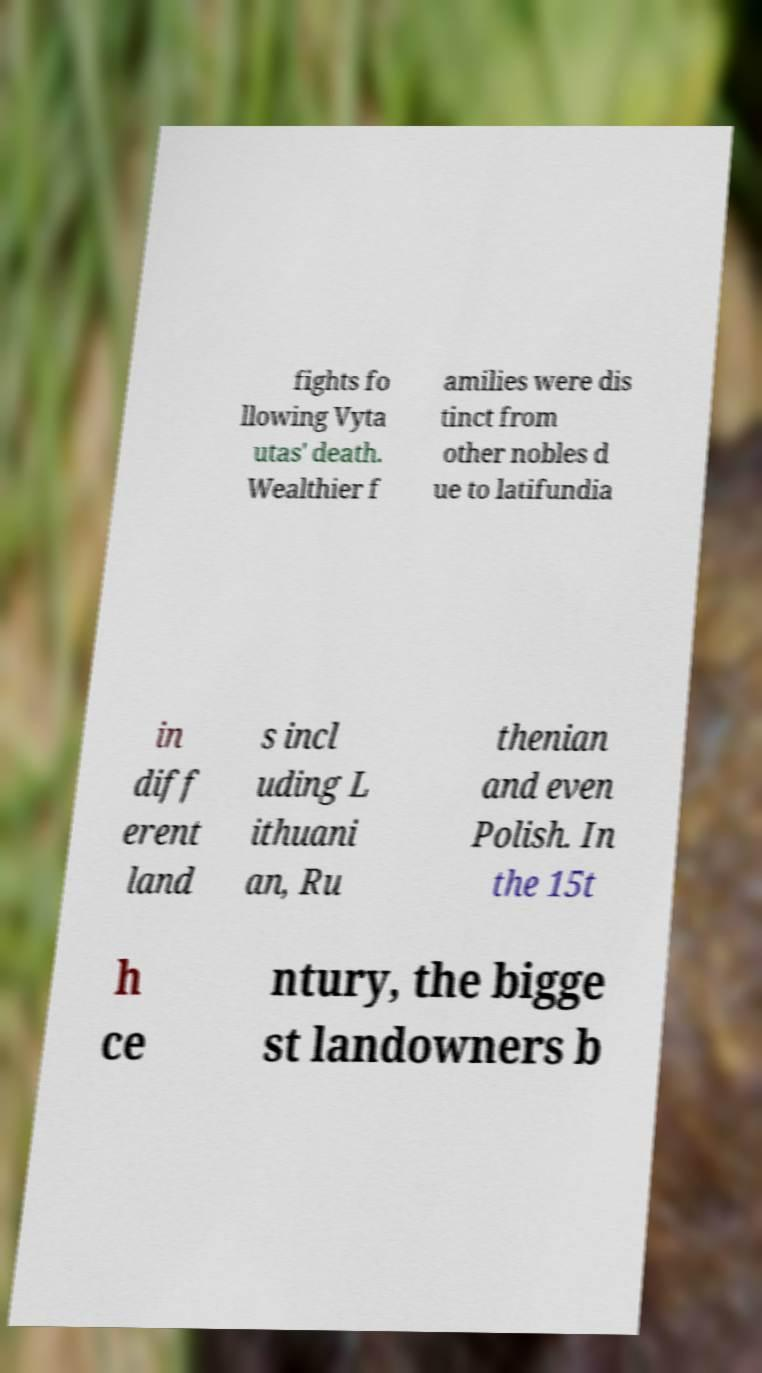Please read and relay the text visible in this image. What does it say? fights fo llowing Vyta utas' death. Wealthier f amilies were dis tinct from other nobles d ue to latifundia in diff erent land s incl uding L ithuani an, Ru thenian and even Polish. In the 15t h ce ntury, the bigge st landowners b 